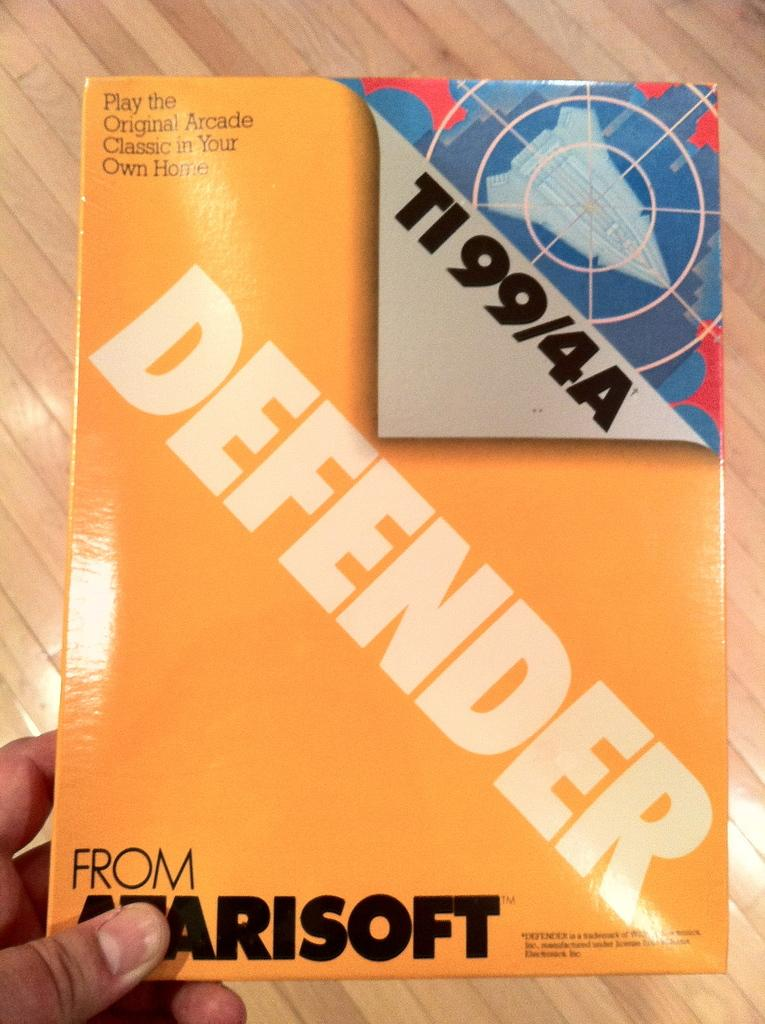<image>
Provide a brief description of the given image. Person holding a book that says "DEFEND" on the cover. 